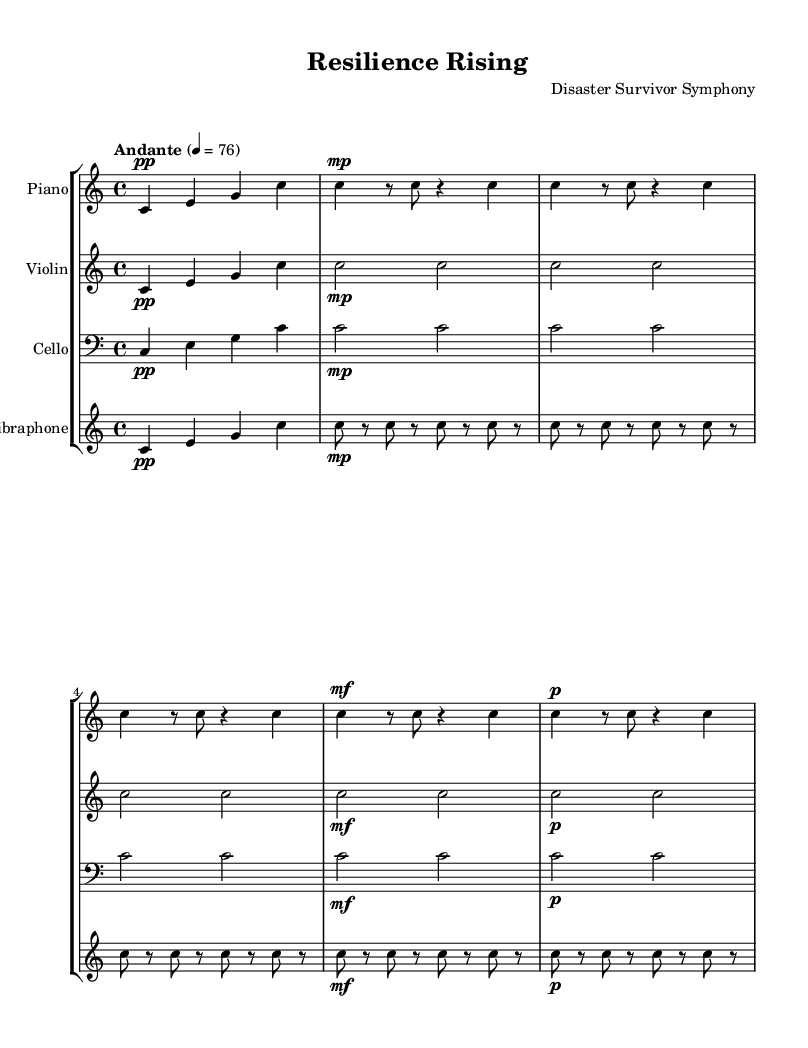What is the key signature of this music? The key signature is indicated at the beginning of the sheet music, where it shows no sharps or flats. This identifies the piece as being in C major.
Answer: C major What is the time signature of this music? The time signature appears at the beginning of the sheet music, and it is written as 4/4, which signifies four beats per measure and a quarter note receives one beat.
Answer: 4/4 What is the tempo marking for this piece? The tempo marking is written in Italian and appears above the staff, stating "Andante," which indicates a moderately slow pace. It is followed by the specific metronome marking of 76 beats per minute.
Answer: Andante Which instrument plays the highest range notes? By examining the staves, the violin is the instrument that plays in the highest register compared to the others such as piano, cello, and vibraphone.
Answer: Violin How many measures are in the piano part? The number of measures can be counted directly from the piano part on the sheet music; there is a repetitive structure, and here it is clearly written out for a total of five measures.
Answer: 5 What dynamic marking is first seen in the vibraphone? The dynamic marking at the beginning of the vibraphone staff shows "pp," which means pianissimo, indicating a very soft sound at the start of the piece.
Answer: pp What type of composition is represented in this sheet music? The overall structure and minimalistic style of the piece, along with the emotional context in the title "Resilience Rising," suggest that this composition is categorized as experimental.
Answer: Experimental 